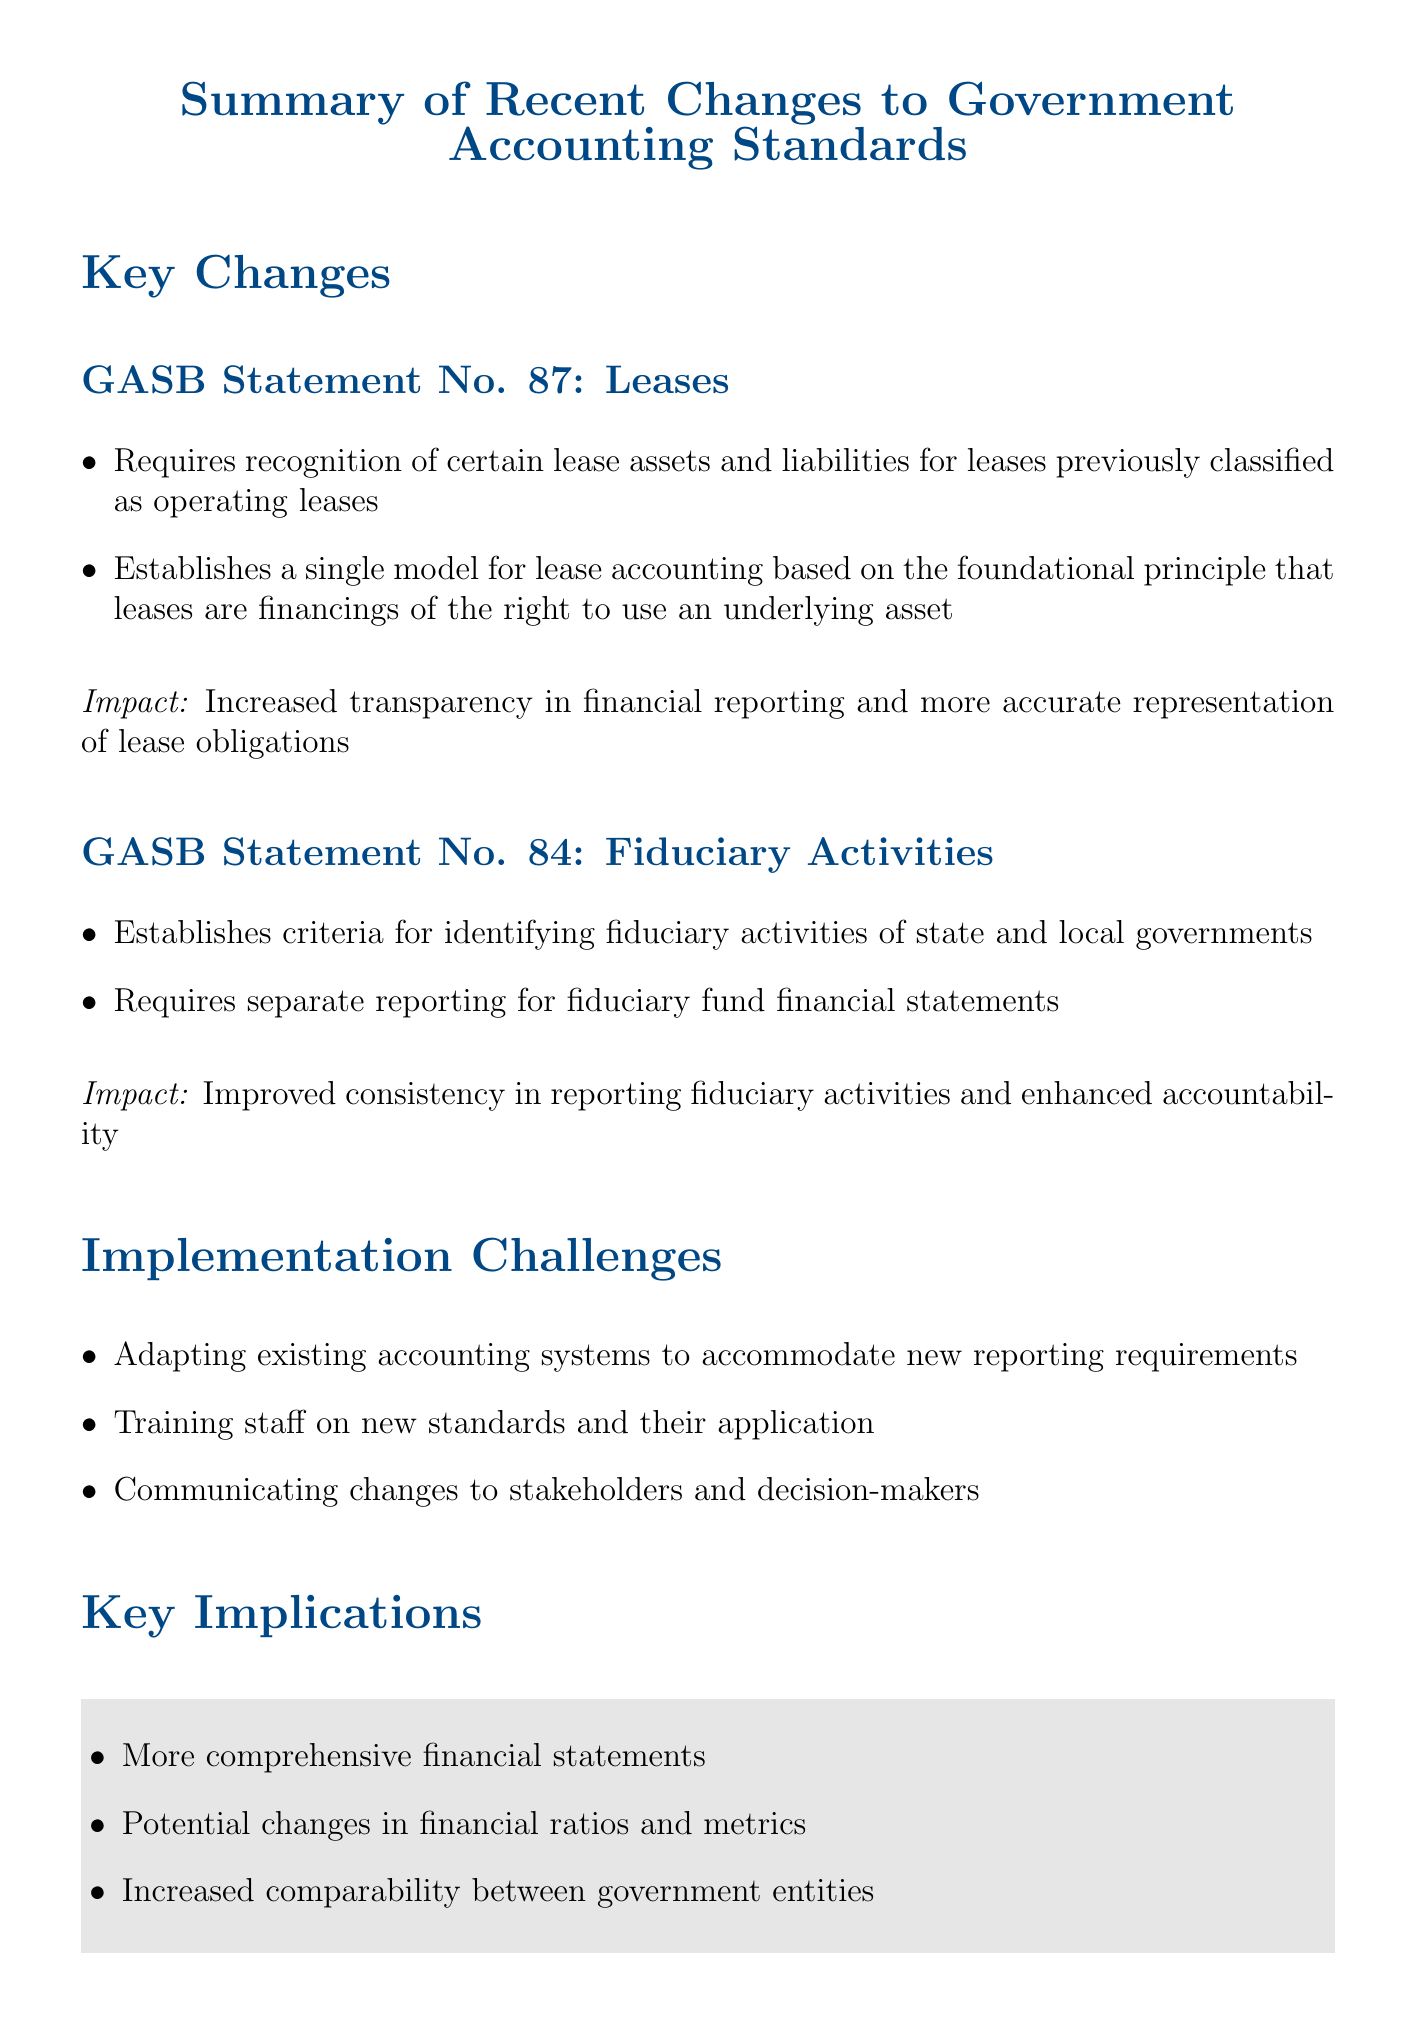What is the title of GASB Statement No. 87? GASB Statement No. 87 pertains to leases, providing guidance on accounting for them.
Answer: Leases What is the effective date for GASB Statement No. 84? The document states that GASB Statement No. 84 is effective for reporting periods beginning after a certain date.
Answer: December 15, 2019 What impact does GASB Statement No. 87 have on financial reporting? The document notes that GASB Statement No. 87 leads to increased transparency and a more accurate representation of lease obligations.
Answer: Increased transparency What is one implementation challenge mentioned in the document? The document lists several challenges that organizations may face when implementing the new standards, including a specific aspect.
Answer: Training staff What is one key implication of the recent changes to government accounting standards? The document describes several implications, highlighting one significant change affecting financial statements.
Answer: More comprehensive financial statements Who can provide guidance on compliance with the new standards? The document lists organizations and their URLs that can assist with compliance issues related to the new standards.
Answer: GASB and AICPA What does GASB Statement No. 84 aim to improve in financial reporting? According to the document, GASB Statement No. 84 seeks to enhance a specific aspect of fiduciary activities reporting.
Answer: Accountability Which standard requires separate reporting for fiduciary fund financial statements? The details in the document specify which GASB standard includes this requirement.
Answer: GASB Statement No. 84 